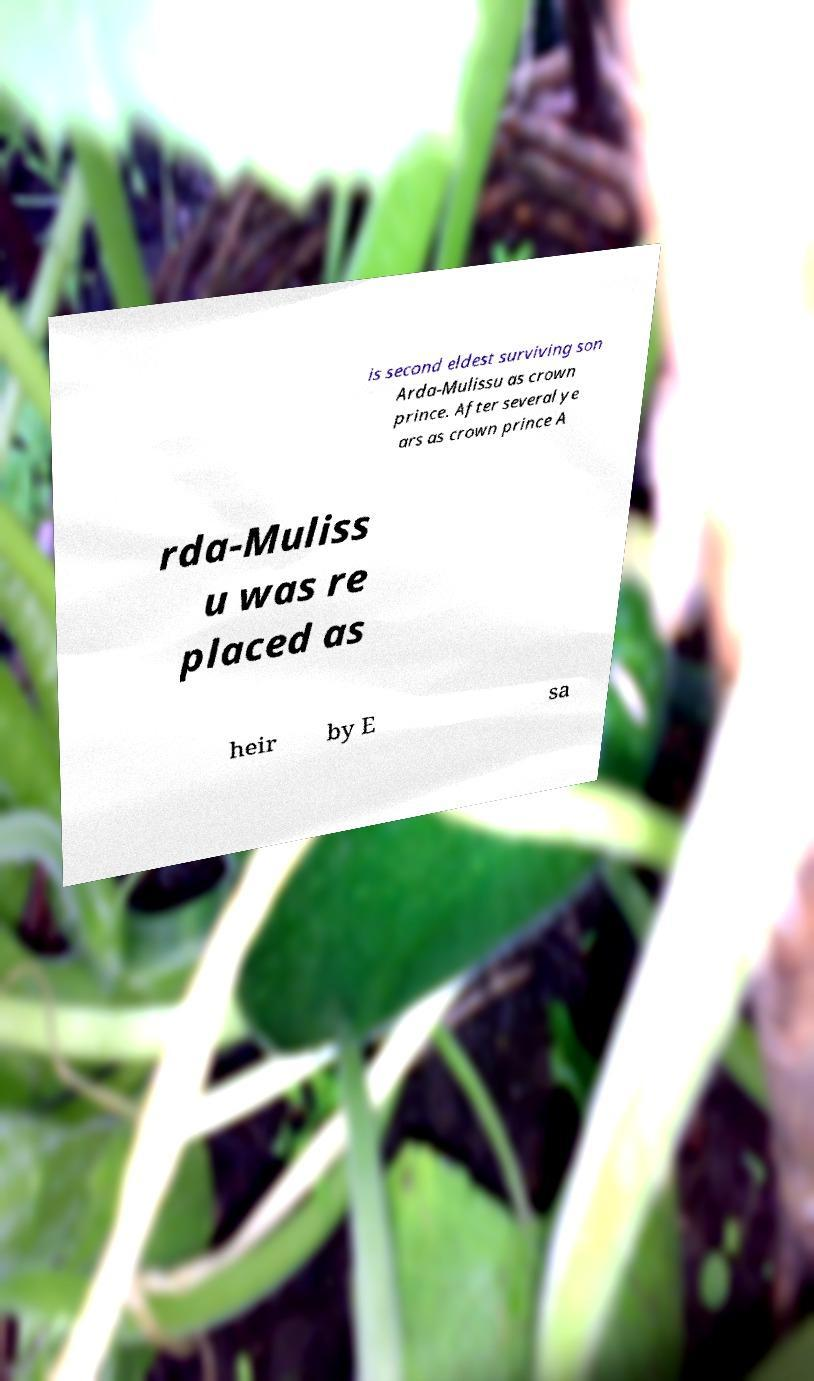Please read and relay the text visible in this image. What does it say? is second eldest surviving son Arda-Mulissu as crown prince. After several ye ars as crown prince A rda-Muliss u was re placed as heir by E sa 